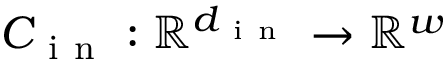<formula> <loc_0><loc_0><loc_500><loc_500>C _ { i n } \colon \mathbb { R } ^ { d _ { i n } } \rightarrow \mathbb { R } ^ { w }</formula> 